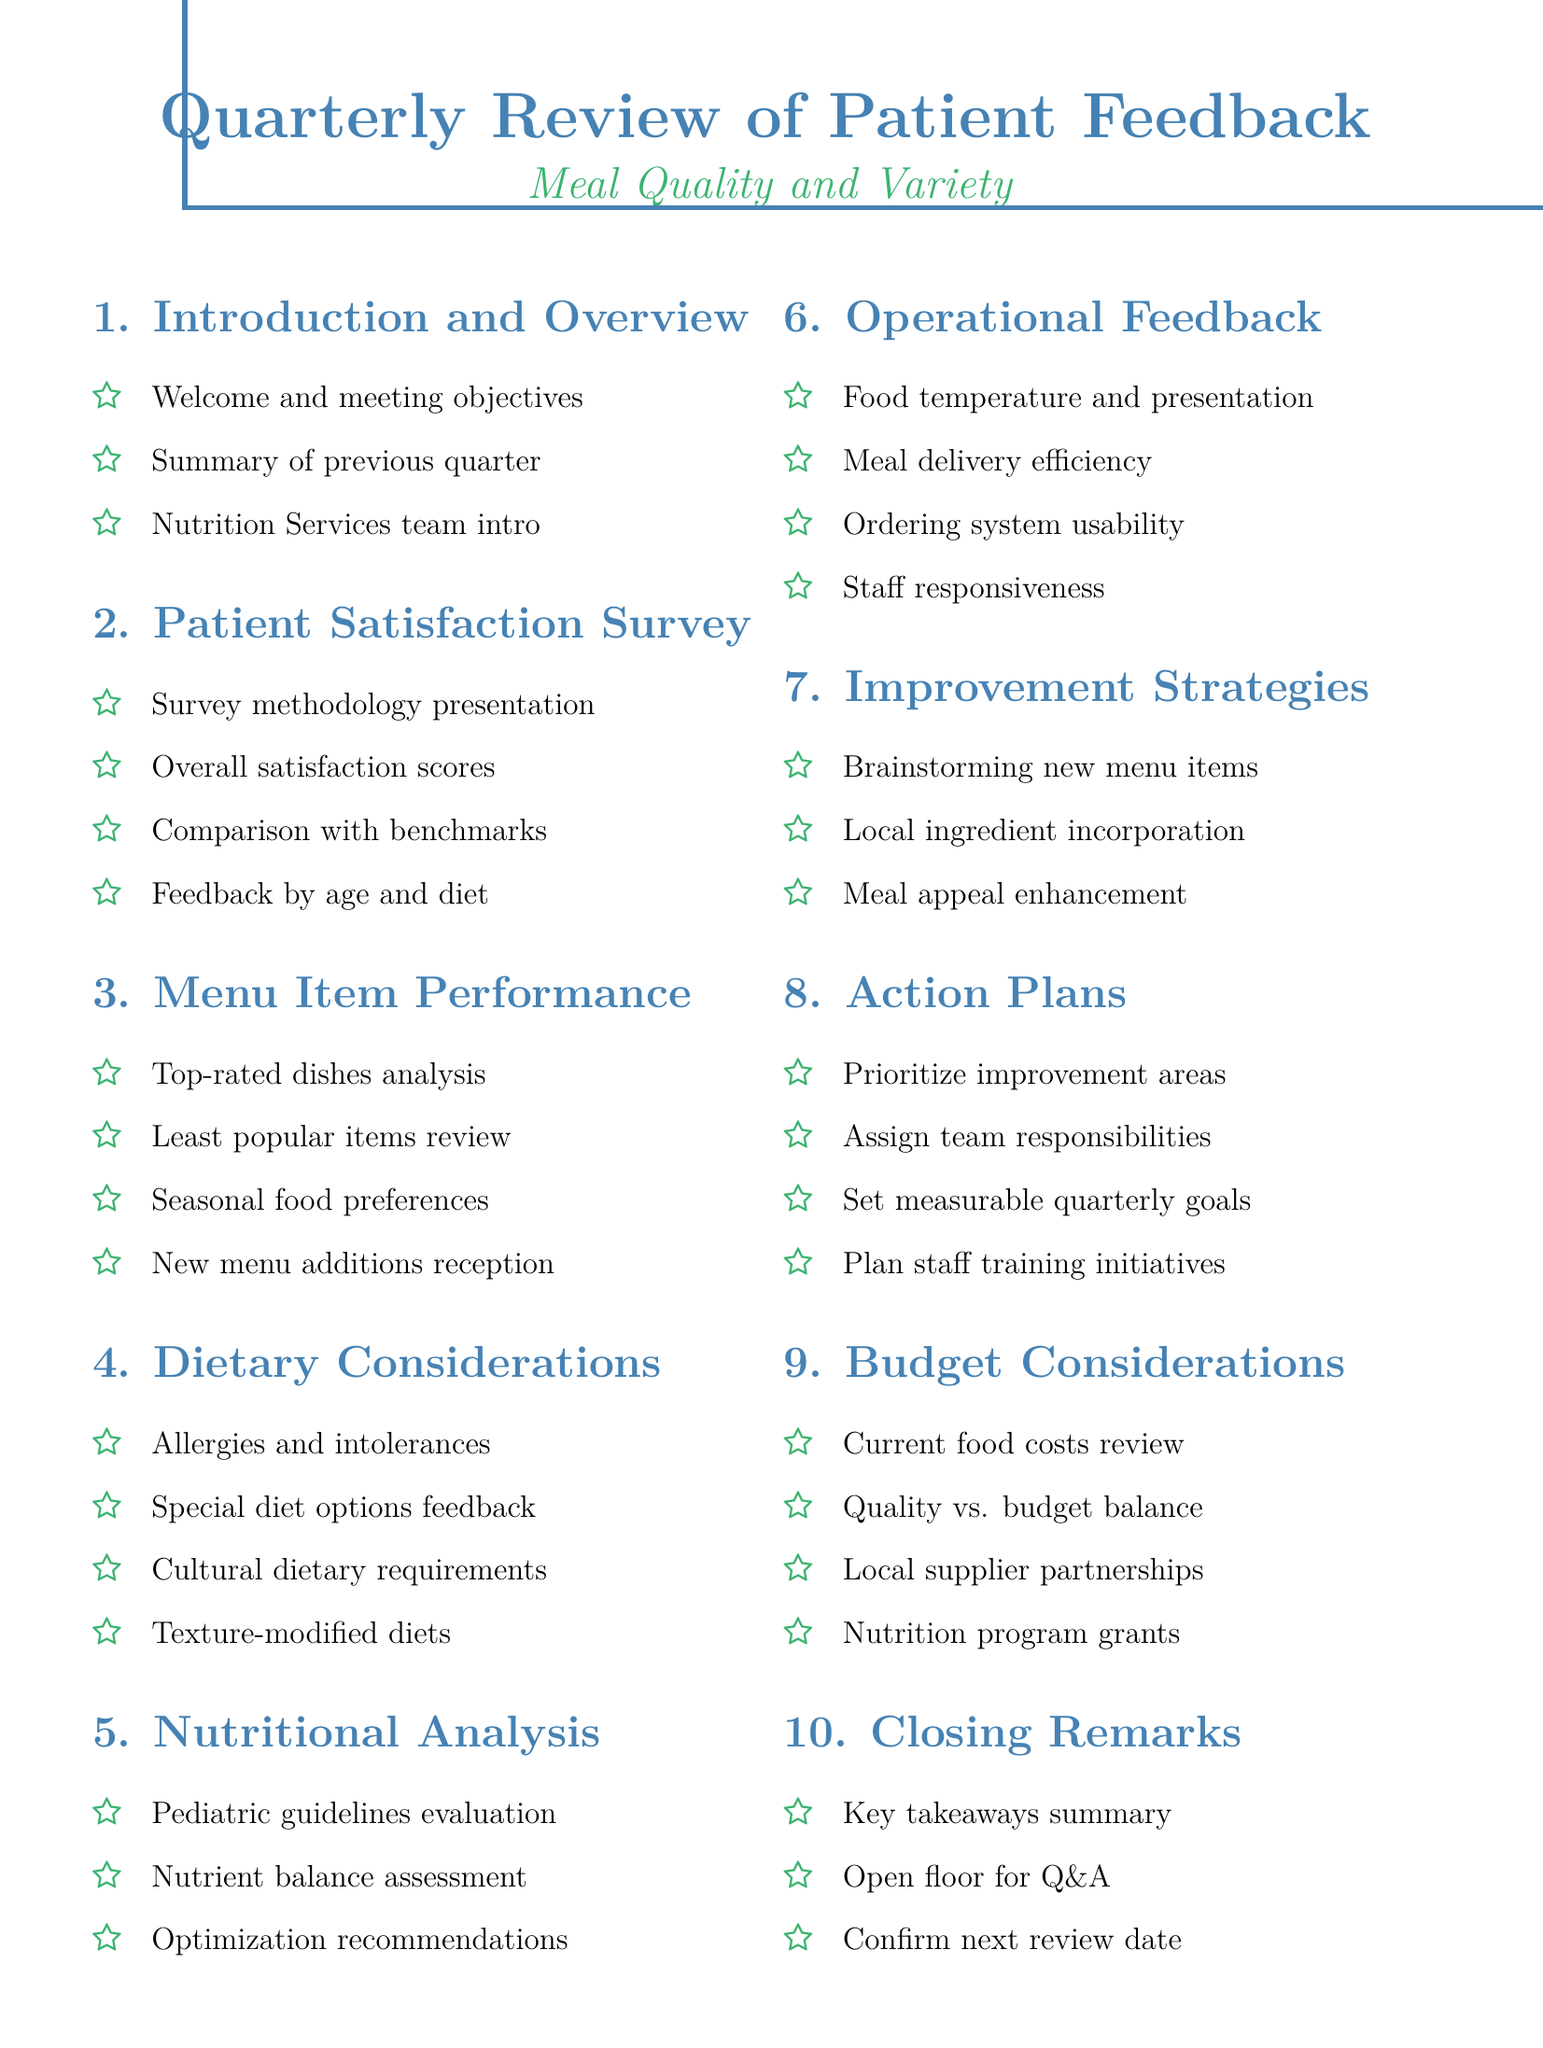What is the title of the meeting? The title of the meeting is stated at the beginning of the document, which is "Quarterly Review of Patient Feedback."
Answer: Quarterly Review of Patient Feedback Who presented the survey methodology? The document mentions that Dr. Sarah Thompson presented the survey methodology during the Patient Satisfaction Survey Results section.
Answer: Dr. Sarah Thompson What section discusses meal delivery efficiency? The Operational Feedback section explicitly mentions meal delivery timing and efficiency as a concern.
Answer: Operational Feedback Which team member leads the Dietary Considerations discussion? The document does not specify a name for the leader of this section, but it is structured as a review discussion, so it's implied to be part of the collaborative team.
Answer: Not specified What was a highlighted aspect in the Menu Item Performance Analysis? The analysis covers top-rated dishes along with their nutritional profiles as a significant aspect.
Answer: Top-rated dishes How many agenda items are listed in total? The document has ten sections outlined as agenda items, which can be counted.
Answer: Ten What is one of the recommendations in the Nutritional Analysis section? The recommendations involve optimizing nutritional content as indicated in the details of that section.
Answer: Optimizing nutritional content What is prioritized in the Action Plans and Next Steps? The action plans include the prioritization of improvement areas for the next quarter.
Answer: Prioritization of improvement areas Who is responsible for reviewing current food costs? The document states that Finance Manager David Okafor is responsible for reviewing current food costs.
Answer: David Okafor What is the closing action mentioned in the Closing Remarks? The closing remarks include an open floor for additional comments and questions as the final action.
Answer: Open floor for Q&A 